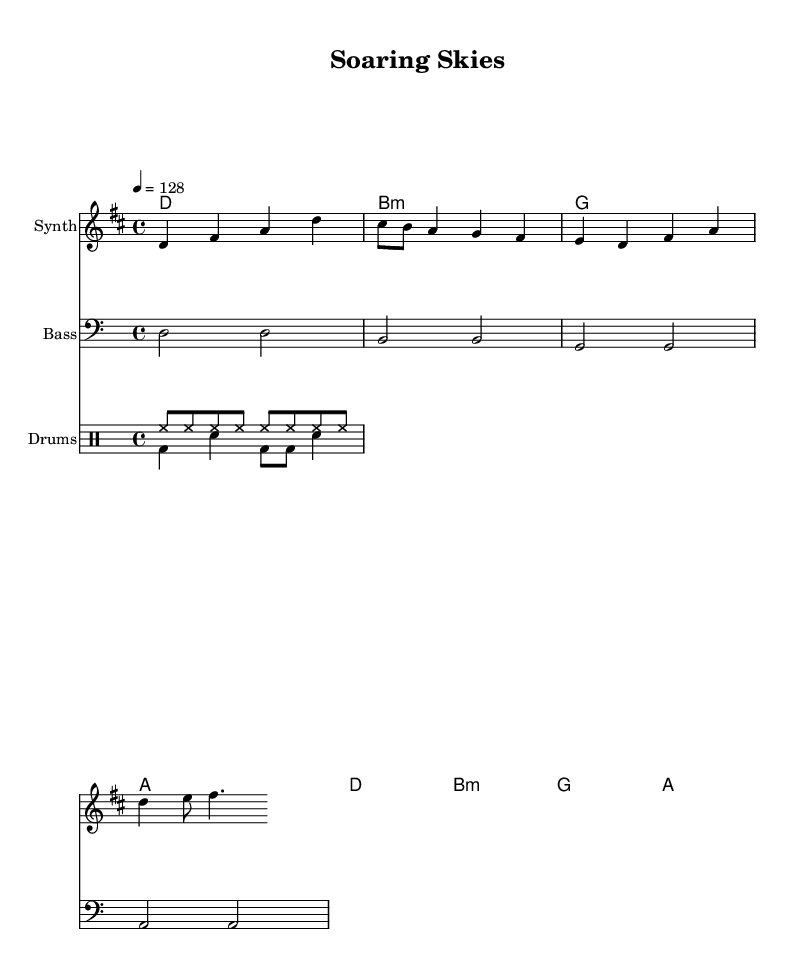What is the key signature of this music? The key signature is indicated by the number of sharps or flats at the beginning of the staff. In this music, it shows two sharps (F# and C#), which indicates the key of D major.
Answer: D major What is the time signature of this music? The time signature is found at the beginning of the piece, indicated as a fraction. This music shows a '4/4' time signature, meaning there are four beats in each measure, and the quarter note gets one beat.
Answer: 4/4 What is the tempo marking of this music? The tempo marking is found at the beginning of the score, indicated with a numeral and a term. This music indicates a tempo of '4 = 128', meaning there are 128 beats per minute.
Answer: 128 How many measures are in the melody? To find the number of measures in the melody, count the number of times the bar lines appear in the melody section. There are 4 bar lines, indicating 4 measures in total.
Answer: 4 Which note is played first in the melody? The first note in the melody section is found at the start of the melody and is the first pitch written in the sequence. The first note is a D, indicating the note being played.
Answer: D What is the role of the bassline in this dance music? The bassline typically provides the rhythmic foundation and reinforces the harmony. In this case, the bassline explores the same root notes of the chords used, which supports the melody and provides a fuller sound.
Answer: Foundation What style of dance music does this piece represent? The energetic tempo, rhythmic drive from the drums, and repetitive melodic patterns reflect characteristics of high-energy dance music, often associated with celebration or festive themes. This piece celebrates technological advancements in aerospace, aligning with a modern dance style.
Answer: High-energy dance 